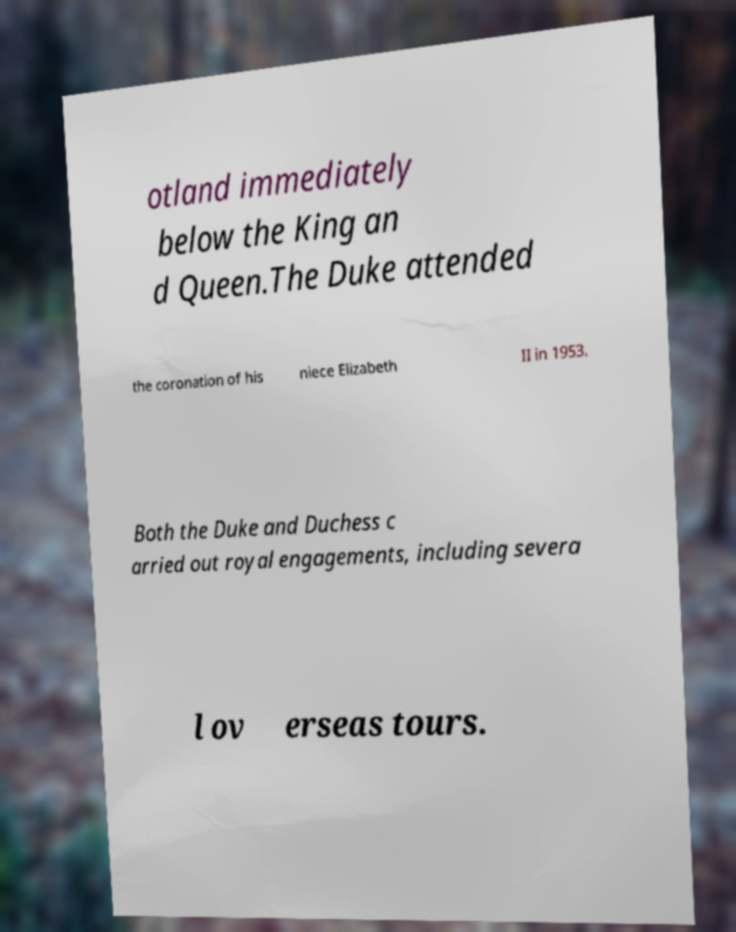Can you read and provide the text displayed in the image?This photo seems to have some interesting text. Can you extract and type it out for me? otland immediately below the King an d Queen.The Duke attended the coronation of his niece Elizabeth II in 1953. Both the Duke and Duchess c arried out royal engagements, including severa l ov erseas tours. 